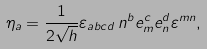<formula> <loc_0><loc_0><loc_500><loc_500>\eta _ { a } = \frac { 1 } { 2 \sqrt { h } } \varepsilon _ { a b c d } \, n ^ { b } e ^ { c } _ { m } e ^ { d } _ { n } \varepsilon ^ { m n } ,</formula> 